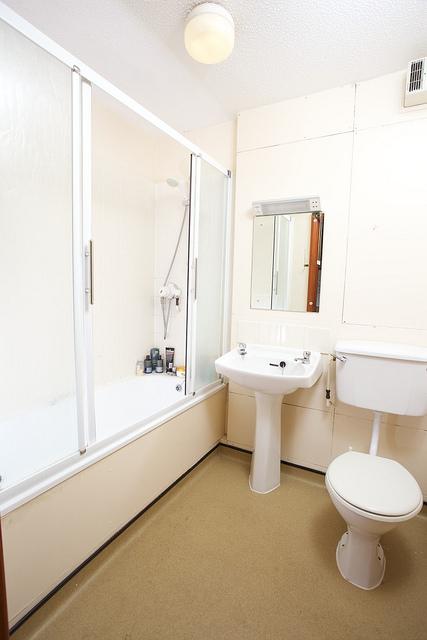Do you see a picture?
Give a very brief answer. No. Is this room carpeted?
Quick response, please. No. What are the gray/black objects inside the shower?
Keep it brief. Shampoo. Is the drain pipe on the sink exposed?
Be succinct. No. Are any of the surfaces reflective?
Keep it brief. Yes. Do you see a chair?
Concise answer only. No. What is above the mirror?
Be succinct. Light. 